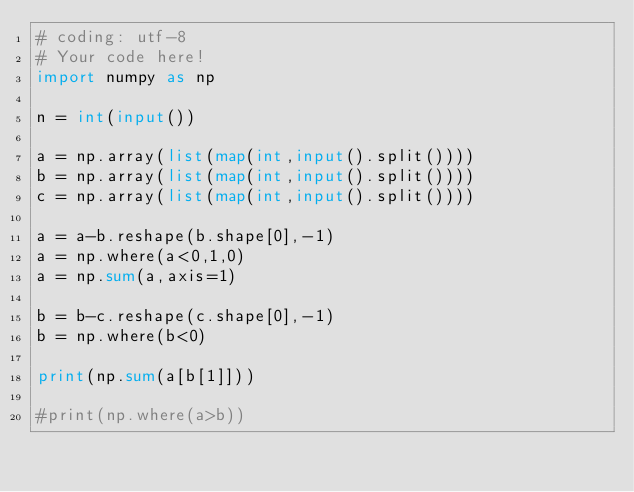<code> <loc_0><loc_0><loc_500><loc_500><_Python_># coding: utf-8
# Your code here!
import numpy as np

n = int(input())

a = np.array(list(map(int,input().split())))
b = np.array(list(map(int,input().split())))
c = np.array(list(map(int,input().split())))

a = a-b.reshape(b.shape[0],-1)
a = np.where(a<0,1,0)
a = np.sum(a,axis=1)

b = b-c.reshape(c.shape[0],-1)
b = np.where(b<0)

print(np.sum(a[b[1]]))

#print(np.where(a>b))

</code> 